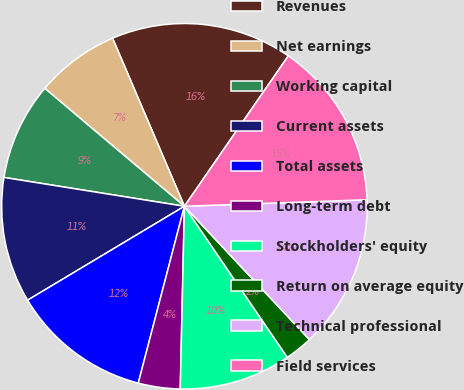Convert chart to OTSL. <chart><loc_0><loc_0><loc_500><loc_500><pie_chart><fcel>Revenues<fcel>Net earnings<fcel>Working capital<fcel>Current assets<fcel>Total assets<fcel>Long-term debt<fcel>Stockholders' equity<fcel>Return on average equity<fcel>Technical professional<fcel>Field services<nl><fcel>16.05%<fcel>7.41%<fcel>8.64%<fcel>11.11%<fcel>12.35%<fcel>3.7%<fcel>9.88%<fcel>2.47%<fcel>13.58%<fcel>14.81%<nl></chart> 